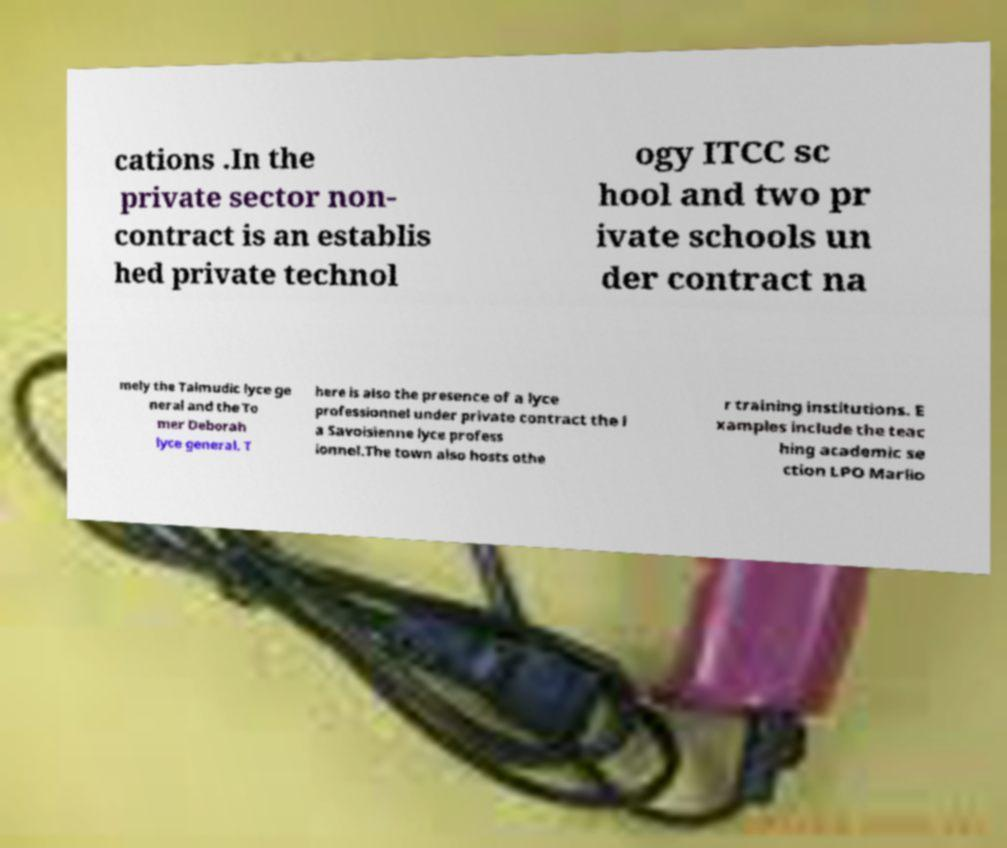Could you assist in decoding the text presented in this image and type it out clearly? cations .In the private sector non- contract is an establis hed private technol ogy ITCC sc hool and two pr ivate schools un der contract na mely the Talmudic lyce ge neral and the To mer Deborah lyce general. T here is also the presence of a lyce professionnel under private contract the l a Savoisienne lyce profess ionnel.The town also hosts othe r training institutions. E xamples include the teac hing academic se ction LPO Marlio 